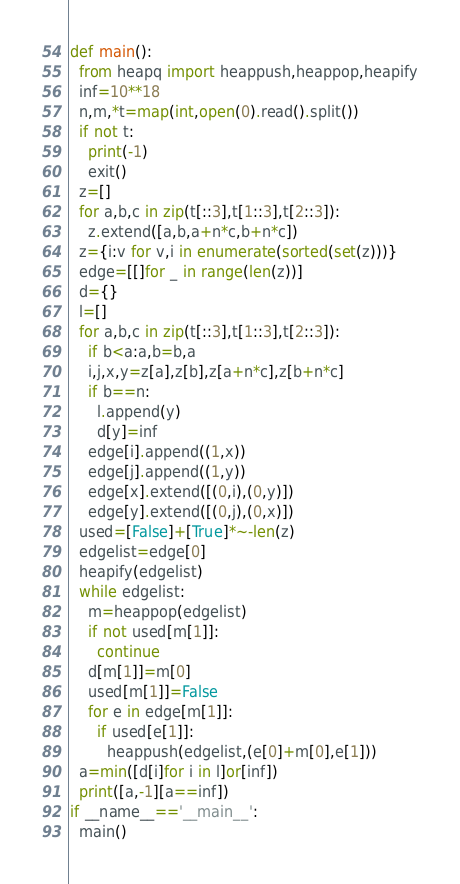<code> <loc_0><loc_0><loc_500><loc_500><_Python_>def main():
  from heapq import heappush,heappop,heapify
  inf=10**18
  n,m,*t=map(int,open(0).read().split())
  if not t:
    print(-1)
    exit()
  z=[]
  for a,b,c in zip(t[::3],t[1::3],t[2::3]):
    z.extend([a,b,a+n*c,b+n*c])
  z={i:v for v,i in enumerate(sorted(set(z)))}
  edge=[[]for _ in range(len(z))]
  d={}
  l=[]
  for a,b,c in zip(t[::3],t[1::3],t[2::3]):
    if b<a:a,b=b,a
    i,j,x,y=z[a],z[b],z[a+n*c],z[b+n*c]
    if b==n:
      l.append(y)
      d[y]=inf
    edge[i].append((1,x))
    edge[j].append((1,y))
    edge[x].extend([(0,i),(0,y)])
    edge[y].extend([(0,j),(0,x)])
  used=[False]+[True]*~-len(z)
  edgelist=edge[0]
  heapify(edgelist)
  while edgelist:
    m=heappop(edgelist)
    if not used[m[1]]:
      continue
    d[m[1]]=m[0]
    used[m[1]]=False
    for e in edge[m[1]]:
      if used[e[1]]:
        heappush(edgelist,(e[0]+m[0],e[1]))
  a=min([d[i]for i in l]or[inf])
  print([a,-1][a==inf])
if __name__=='__main__':
  main()</code> 